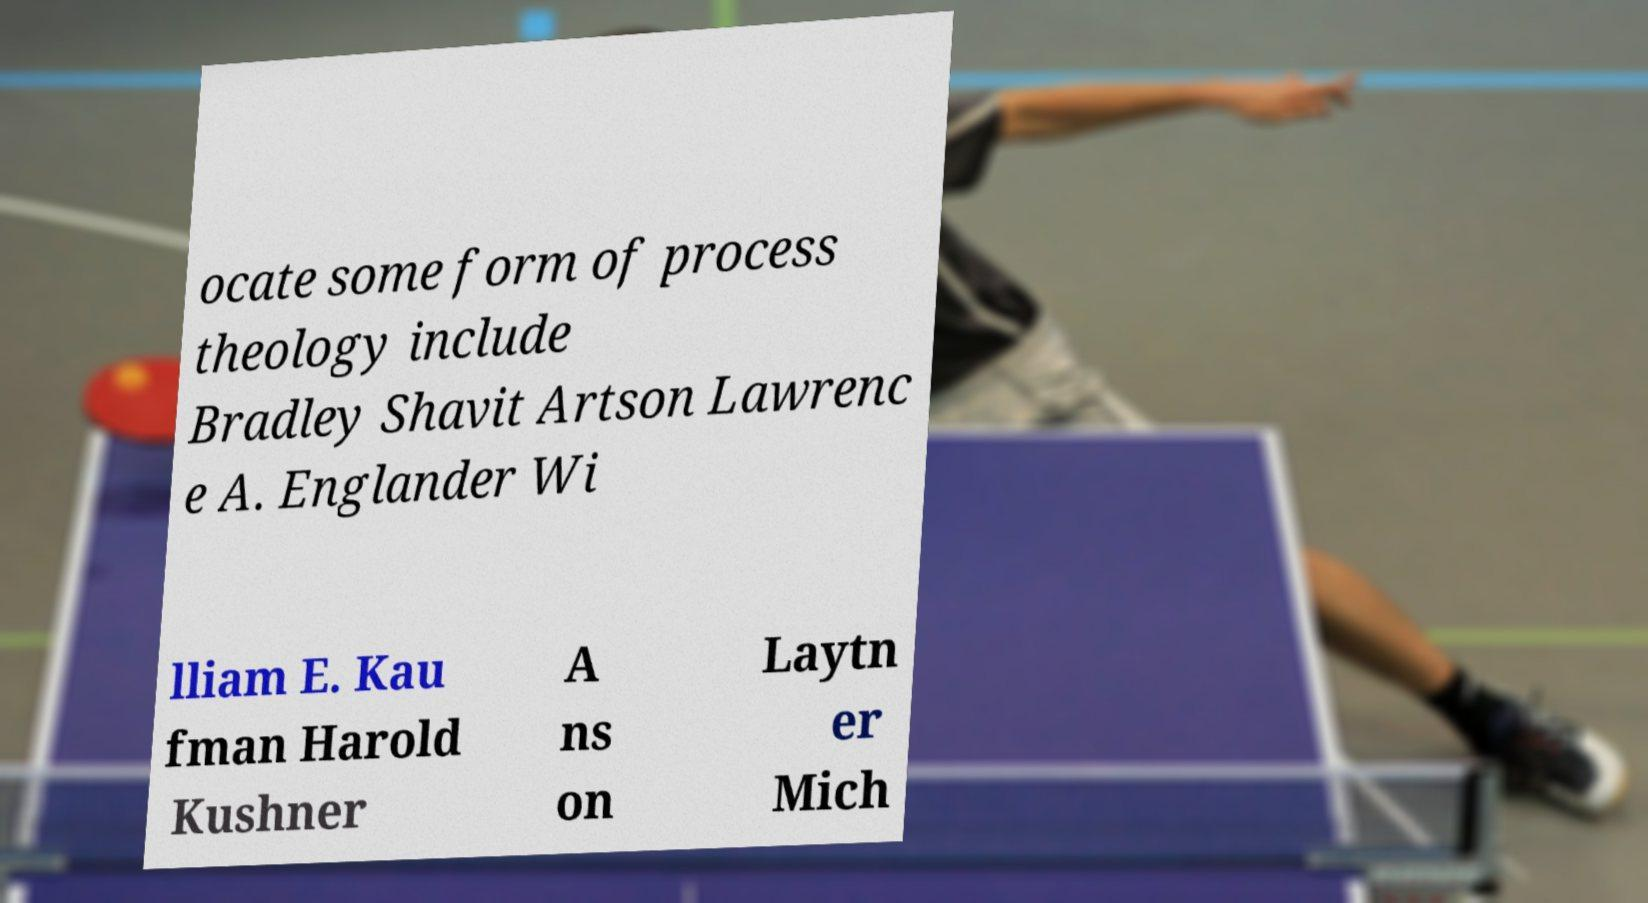Could you assist in decoding the text presented in this image and type it out clearly? ocate some form of process theology include Bradley Shavit Artson Lawrenc e A. Englander Wi lliam E. Kau fman Harold Kushner A ns on Laytn er Mich 